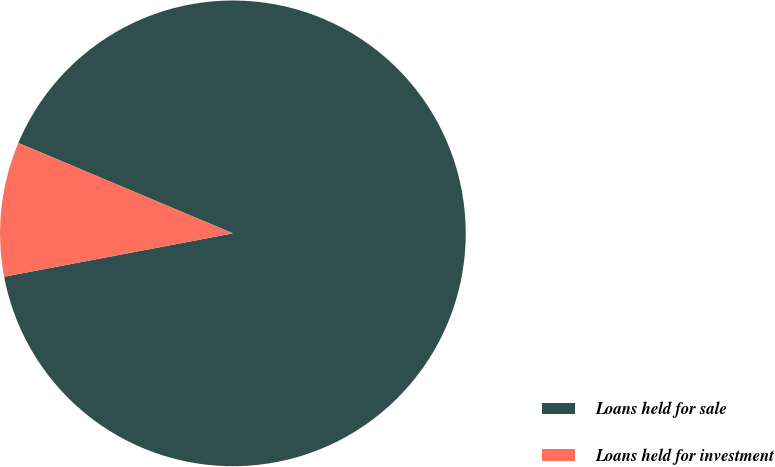Convert chart. <chart><loc_0><loc_0><loc_500><loc_500><pie_chart><fcel>Loans held for sale<fcel>Loans held for investment<nl><fcel>90.67%<fcel>9.33%<nl></chart> 